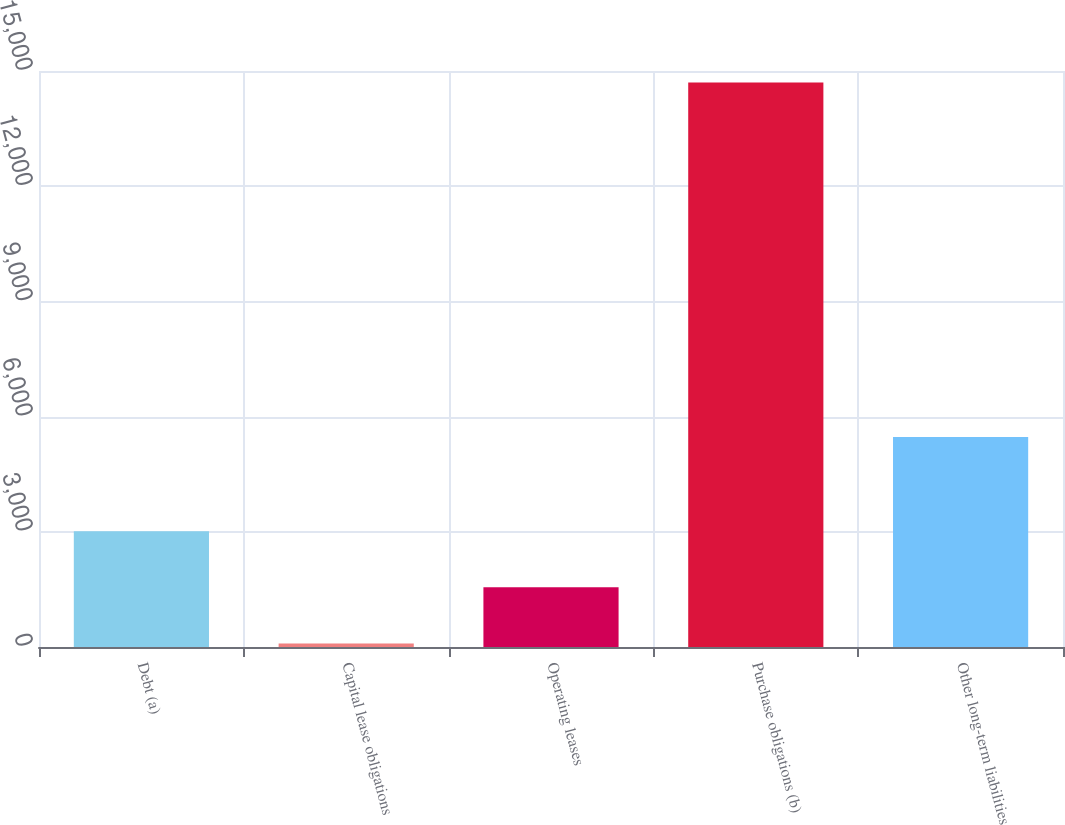<chart> <loc_0><loc_0><loc_500><loc_500><bar_chart><fcel>Debt (a)<fcel>Capital lease obligations<fcel>Operating leases<fcel>Purchase obligations (b)<fcel>Other long-term liabilities<nl><fcel>3014.2<fcel>92<fcel>1553.1<fcel>14703<fcel>5468<nl></chart> 